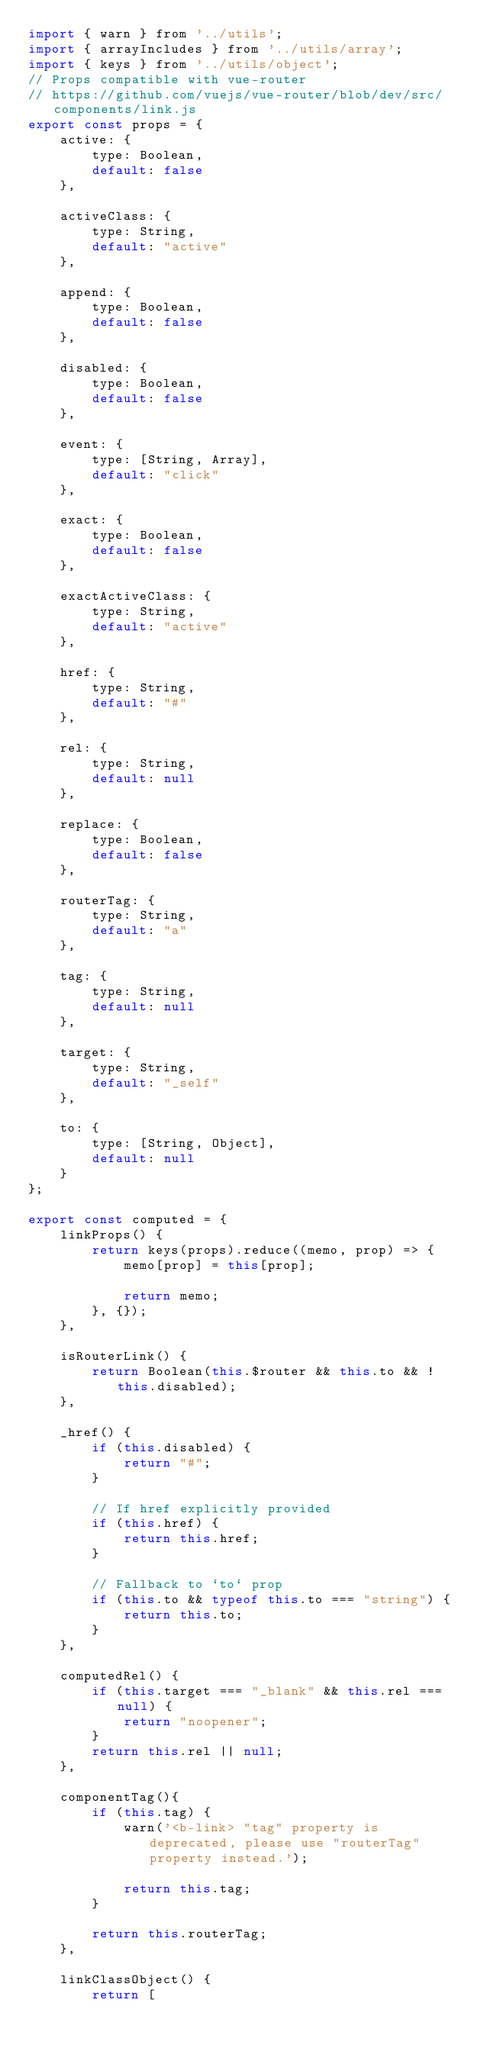Convert code to text. <code><loc_0><loc_0><loc_500><loc_500><_JavaScript_>import { warn } from '../utils';
import { arrayIncludes } from '../utils/array';
import { keys } from '../utils/object';
// Props compatible with vue-router
// https://github.com/vuejs/vue-router/blob/dev/src/components/link.js
export const props = {
    active: {
        type: Boolean,
        default: false
    },

    activeClass: {
        type: String,
        default: "active"
    },

    append: {
        type: Boolean,
        default: false
    },

    disabled: {
        type: Boolean,
        default: false
    },

    event: {
        type: [String, Array],
        default: "click"
    },

    exact: {
        type: Boolean,
        default: false
    },

    exactActiveClass: {
        type: String,
        default: "active"
    },

    href: {
        type: String,
        default: "#"
    },

    rel: {
        type: String,
        default: null
    },

    replace: {
        type: Boolean,
        default: false
    },

    routerTag: {
        type: String,
        default: "a"
    },

    tag: {
        type: String,
        default: null
    },

    target: {
        type: String,
        default: "_self"
    },

    to: {
        type: [String, Object],
        default: null
    }
};

export const computed = {
    linkProps() {
        return keys(props).reduce((memo, prop) => {
            memo[prop] = this[prop];

            return memo;
        }, {});
    },

    isRouterLink() {
        return Boolean(this.$router && this.to && !this.disabled);
    },

    _href() {
        if (this.disabled) {
            return "#";
        }

        // If href explicitly provided
        if (this.href) {
            return this.href;
        }

        // Fallback to `to` prop
        if (this.to && typeof this.to === "string") {
            return this.to;
        }
    },

    computedRel() {
        if (this.target === "_blank" && this.rel === null) {
            return "noopener";
        }
        return this.rel || null;
    },

    componentTag(){
        if (this.tag) {
            warn('<b-link> "tag" property is deprecated, please use "routerTag" property instead.');

            return this.tag;
        }

        return this.routerTag;
    },

    linkClassObject() {
        return [</code> 